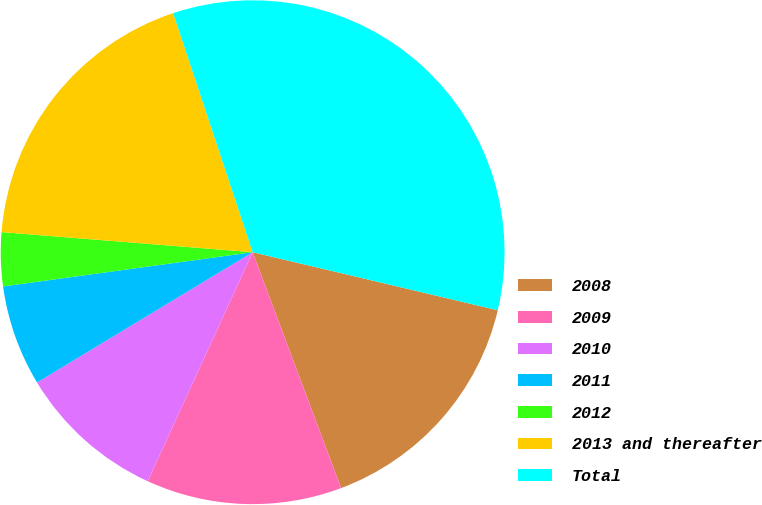<chart> <loc_0><loc_0><loc_500><loc_500><pie_chart><fcel>2008<fcel>2009<fcel>2010<fcel>2011<fcel>2012<fcel>2013 and thereafter<fcel>Total<nl><fcel>15.59%<fcel>12.55%<fcel>9.51%<fcel>6.48%<fcel>3.44%<fcel>18.62%<fcel>33.81%<nl></chart> 